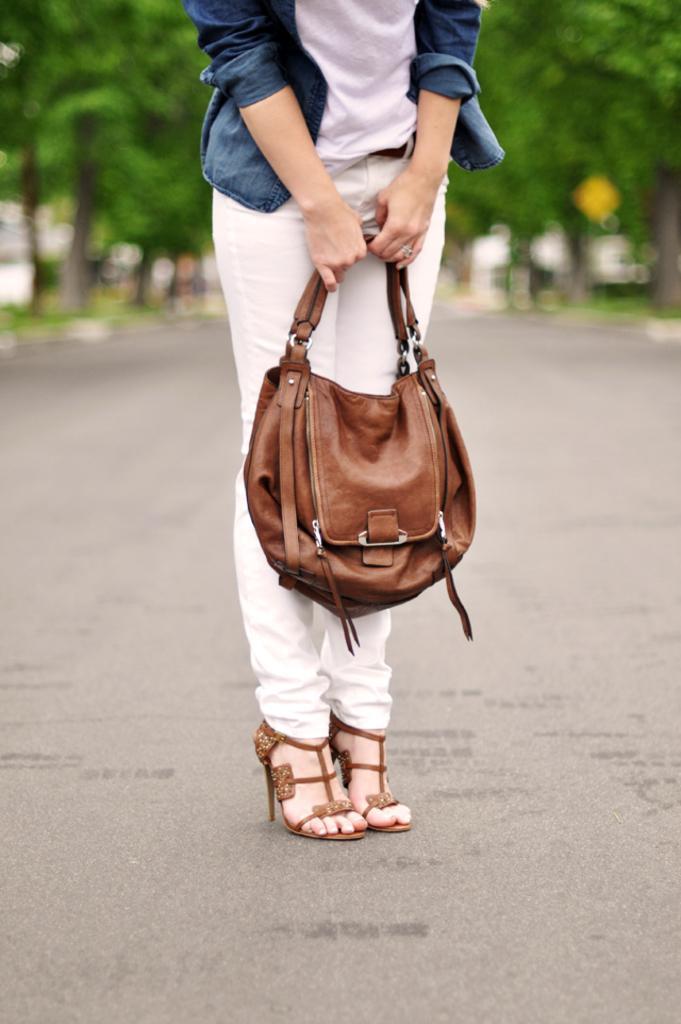How would you summarize this image in a sentence or two? As we can see in the image there are trees and a woman holding handbag. 